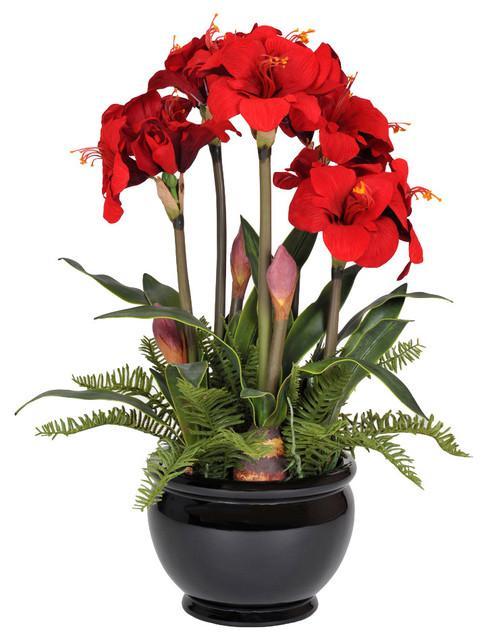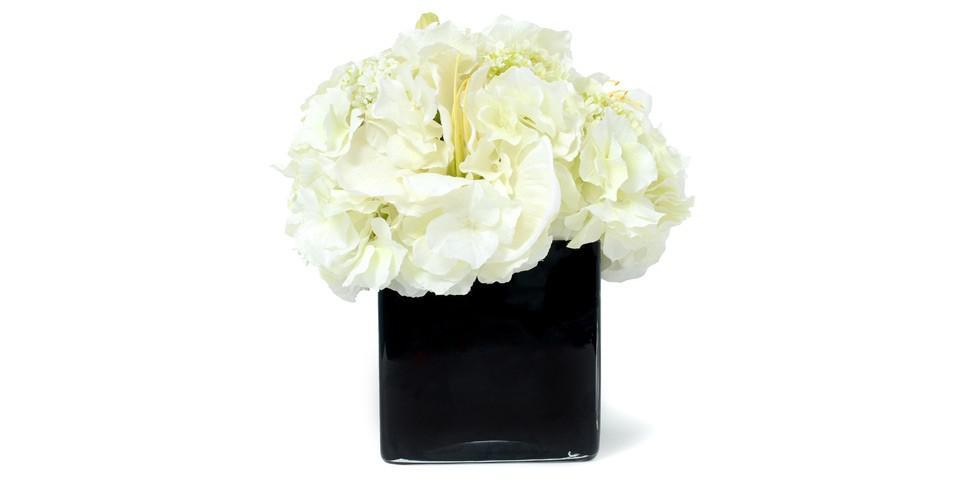The first image is the image on the left, the second image is the image on the right. Analyze the images presented: Is the assertion "The right image contains white flowers in a black vase." valid? Answer yes or no. Yes. The first image is the image on the left, the second image is the image on the right. Examine the images to the left and right. Is the description "A short black vase has red flowers." accurate? Answer yes or no. Yes. 